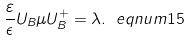Convert formula to latex. <formula><loc_0><loc_0><loc_500><loc_500>\frac { \varepsilon } { \epsilon } U _ { B } \mu U _ { B } ^ { + } = \lambda . \ e q n u m { 1 5 }</formula> 